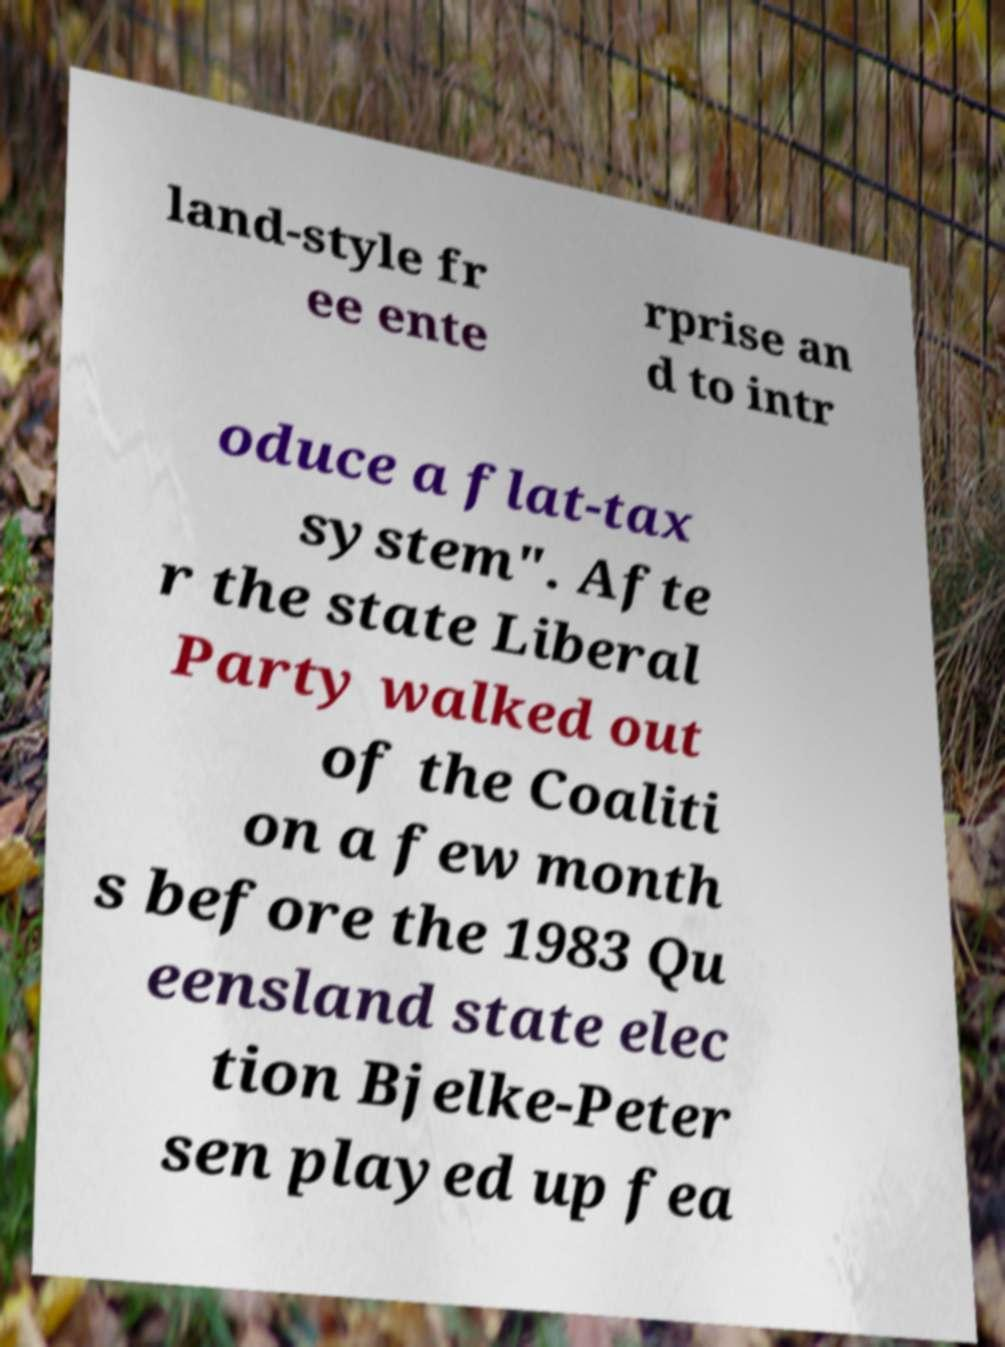Could you extract and type out the text from this image? land-style fr ee ente rprise an d to intr oduce a flat-tax system". Afte r the state Liberal Party walked out of the Coaliti on a few month s before the 1983 Qu eensland state elec tion Bjelke-Peter sen played up fea 